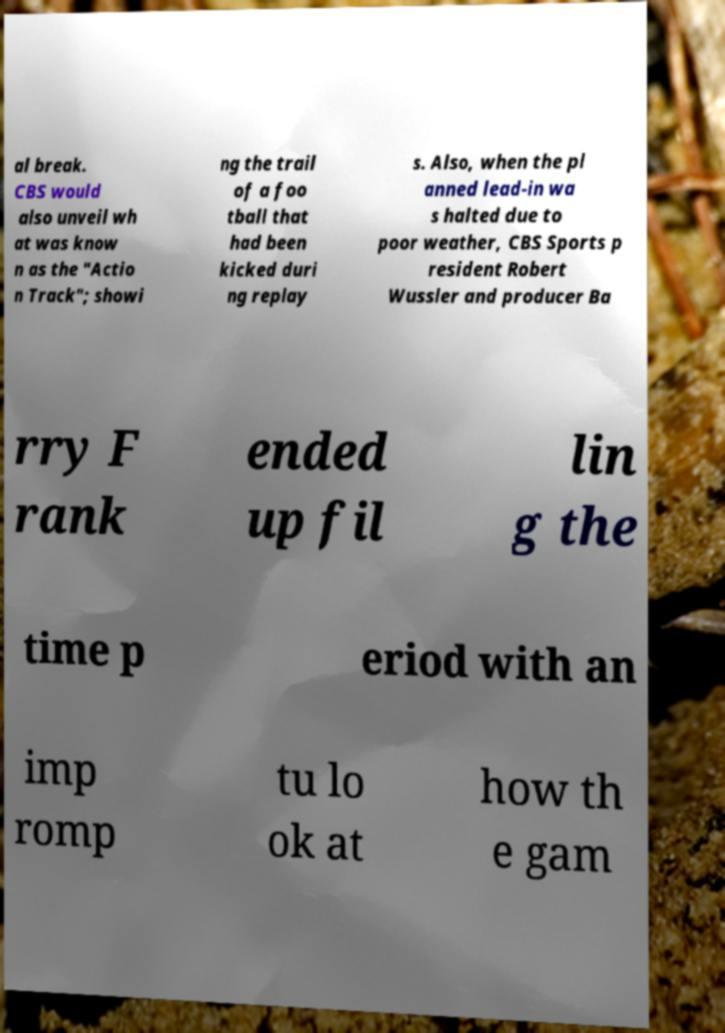Can you read and provide the text displayed in the image?This photo seems to have some interesting text. Can you extract and type it out for me? al break. CBS would also unveil wh at was know n as the "Actio n Track"; showi ng the trail of a foo tball that had been kicked duri ng replay s. Also, when the pl anned lead-in wa s halted due to poor weather, CBS Sports p resident Robert Wussler and producer Ba rry F rank ended up fil lin g the time p eriod with an imp romp tu lo ok at how th e gam 